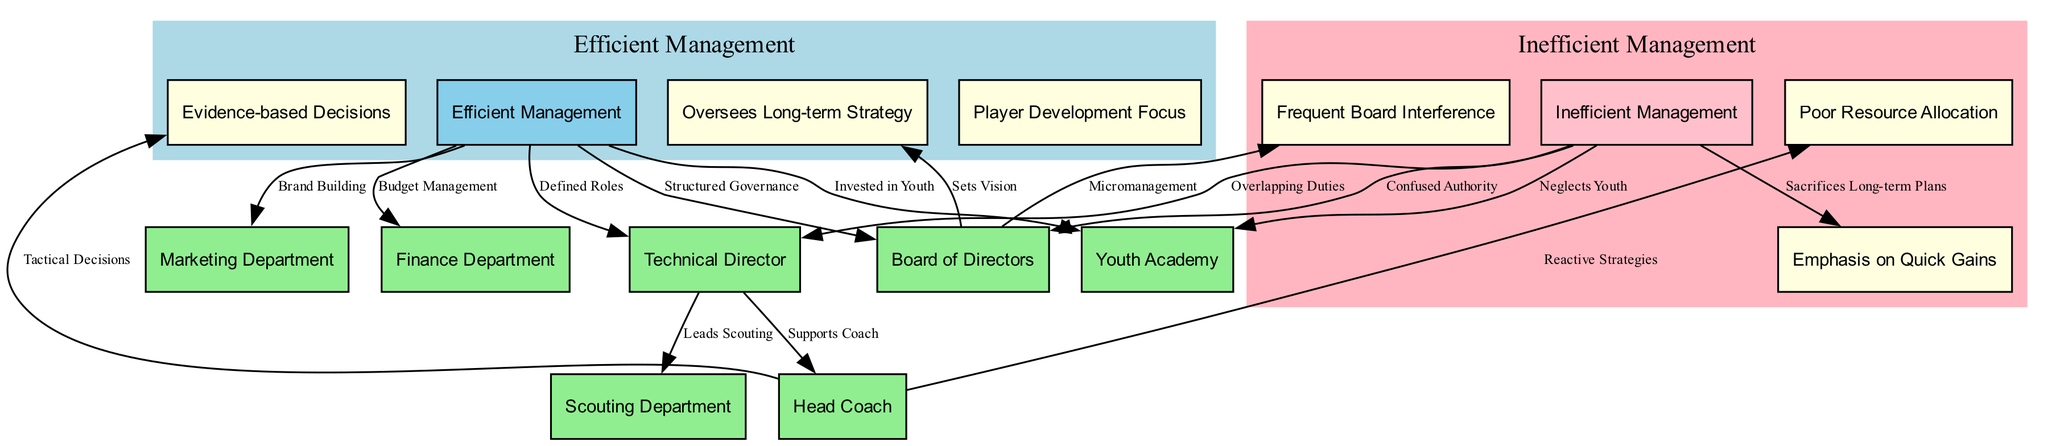What is the main distinction between Efficient and Inefficient Management in the diagram? The distinction is represented by the nodes 'Efficient Management' and 'Inefficient Management'. The efficient management node emphasizes structured governance and defined roles, while the inefficient management node highlights confused authority and overlapping duties.
Answer: Efficient Management and Inefficient Management How many total nodes are there in the diagram? By counting all the nodes listed, there are 15 nodes in total, which include various management components and practices related to efficient and inefficient management.
Answer: 15 What does the arrow from 'Board of Directors' to 'Oversees Long-term Strategy' signify? The arrow indicates that the Board of Directors is responsible for overseeing the long-term strategy of the football club, establishing the vision that guides the organization.
Answer: Oversees Long-term Strategy What type of management emphasizes 'Player Development Focus'? The type of management that emphasizes 'Player Development Focus' is classified under 'Efficient Management', as indicated by the hierarchical structure that connects it to the efficient practices.
Answer: Efficient Management Which node indicates a problem with 'Frequent Board Interference'? The node 'Frequent Board Interference' indicates an issue under 'Inefficient Management', suggesting that micromanagement by the board disrupts effective governance.
Answer: Frequent Board Interference What relationship is suggested between 'Technical Director' and 'Scouting Department'? The relationship indicates that the Technical Director leads the Scouting Department, as represented by the directed edge running from 'Technical Director' to 'Scouting Department'.
Answer: Leads Scouting How does 'Marketing Department' relate to 'Brand Building'? The 'Marketing Department' is involved with 'Brand Building', indicating its role in enhancing the visibility and reputation of the football club.
Answer: Brand Building What management practice sacrifices long-term plans for immediate results? The management practice that sacrifices long-term plans for immediate results is represented by 'Emphasis on Quick Gains', which is part of the 'Inefficient Management' category.
Answer: Emphasis on Quick Gains What does 'Defined Roles' signify in the context of 'Efficient Management'? 'Defined Roles' signifies clarity in responsibilities within 'Efficient Management', contributing to structured governance and allowing each department to operate effectively without overlap.
Answer: Defined Roles 